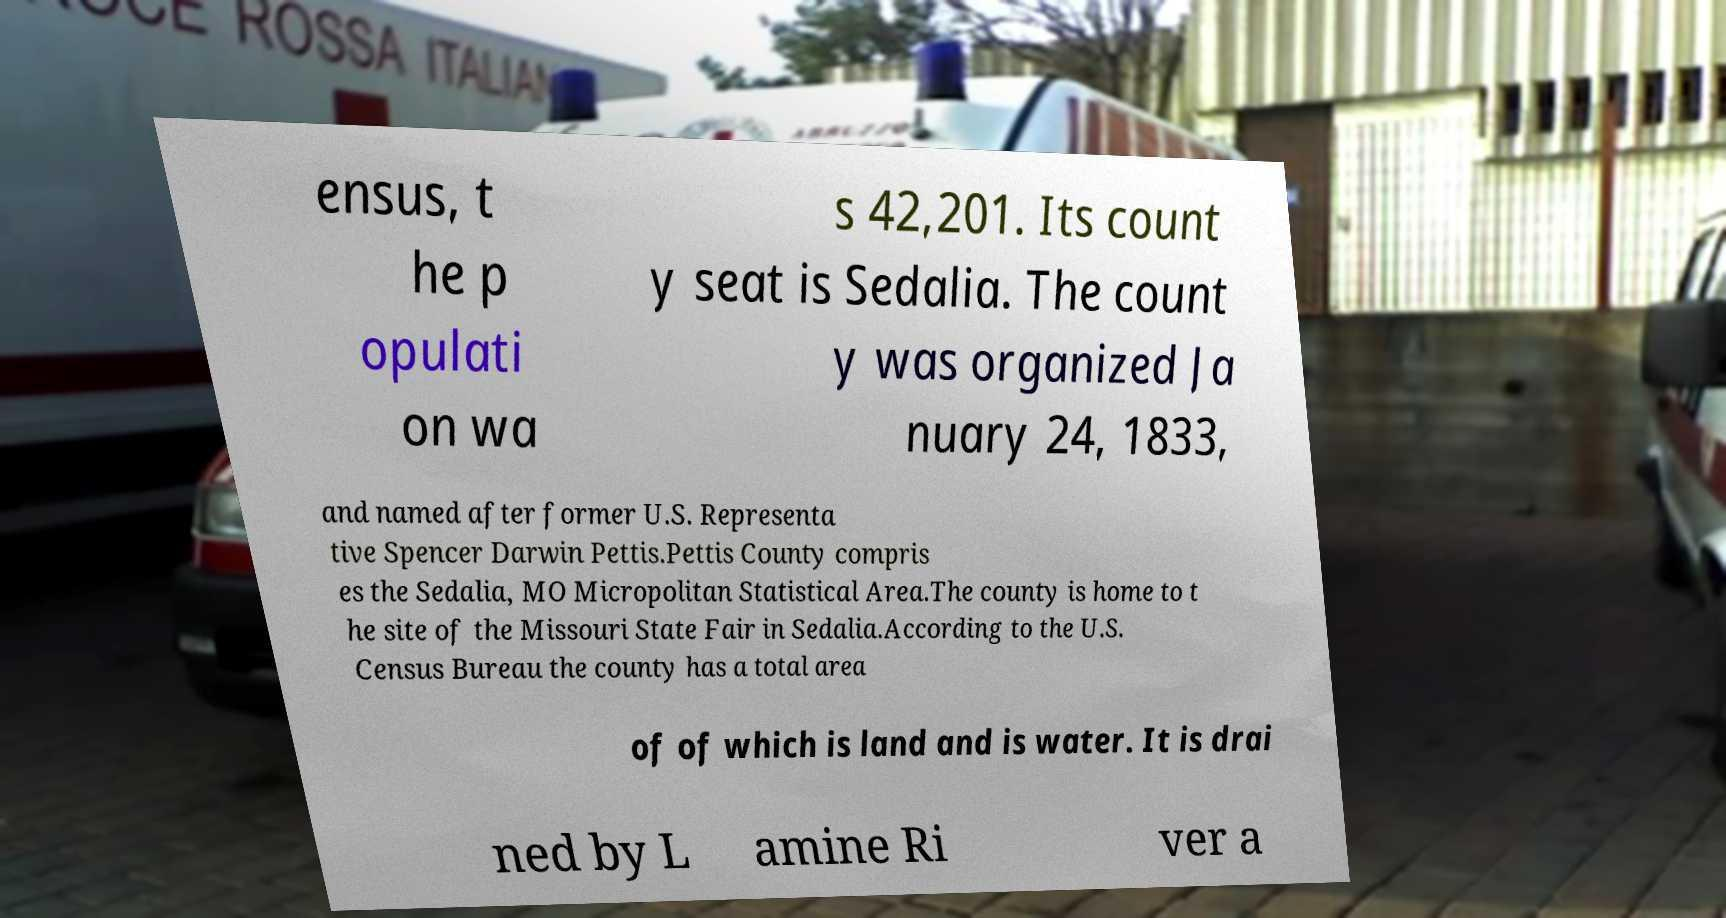Please read and relay the text visible in this image. What does it say? ensus, t he p opulati on wa s 42,201. Its count y seat is Sedalia. The count y was organized Ja nuary 24, 1833, and named after former U.S. Representa tive Spencer Darwin Pettis.Pettis County compris es the Sedalia, MO Micropolitan Statistical Area.The county is home to t he site of the Missouri State Fair in Sedalia.According to the U.S. Census Bureau the county has a total area of of which is land and is water. It is drai ned by L amine Ri ver a 